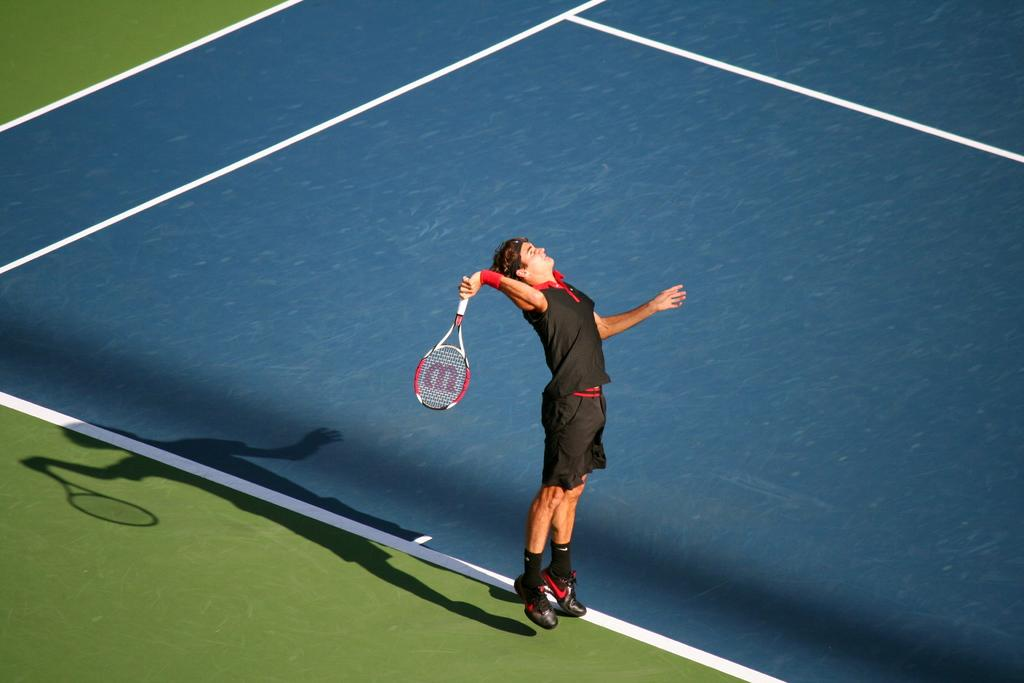What is happening in the image? There is a person in the image who is jumping on a playground. What is the person holding in the image? The person is holding a tennis racket. What type of sea fowl can be seen flying in the image? There is no sea fowl present in the image; it features a person jumping on a playground while holding a tennis racket. What process is being used to create the image? The question about the process used to create the image is not relevant to the facts provided, as we are only discussing the content of the image itself. 